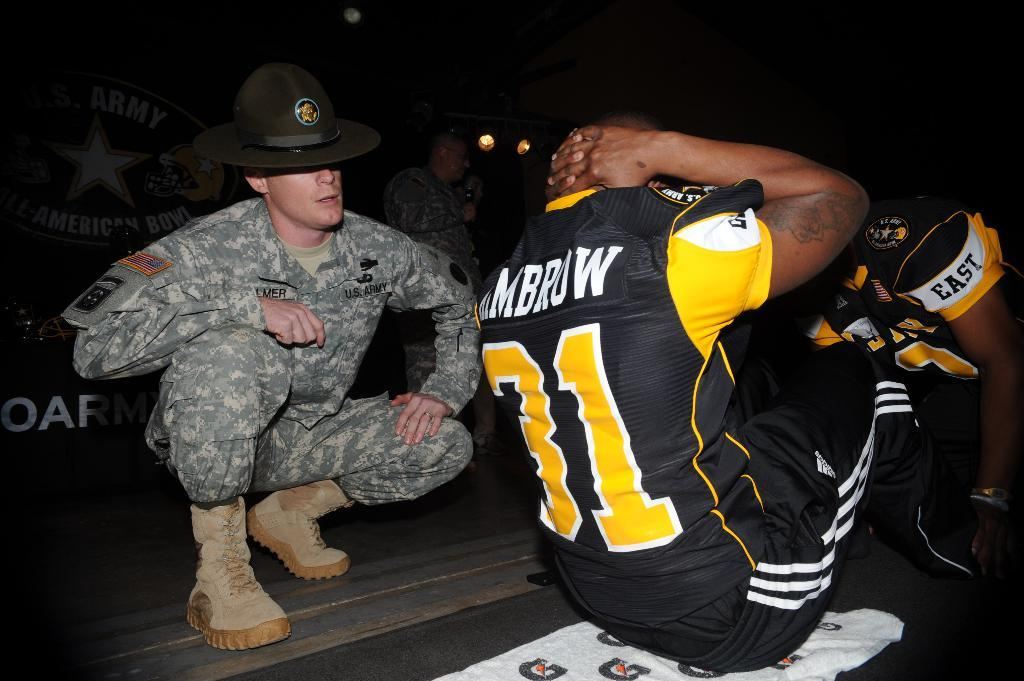<image>
Describe the image concisely. a man with the number 31 on his jersey 